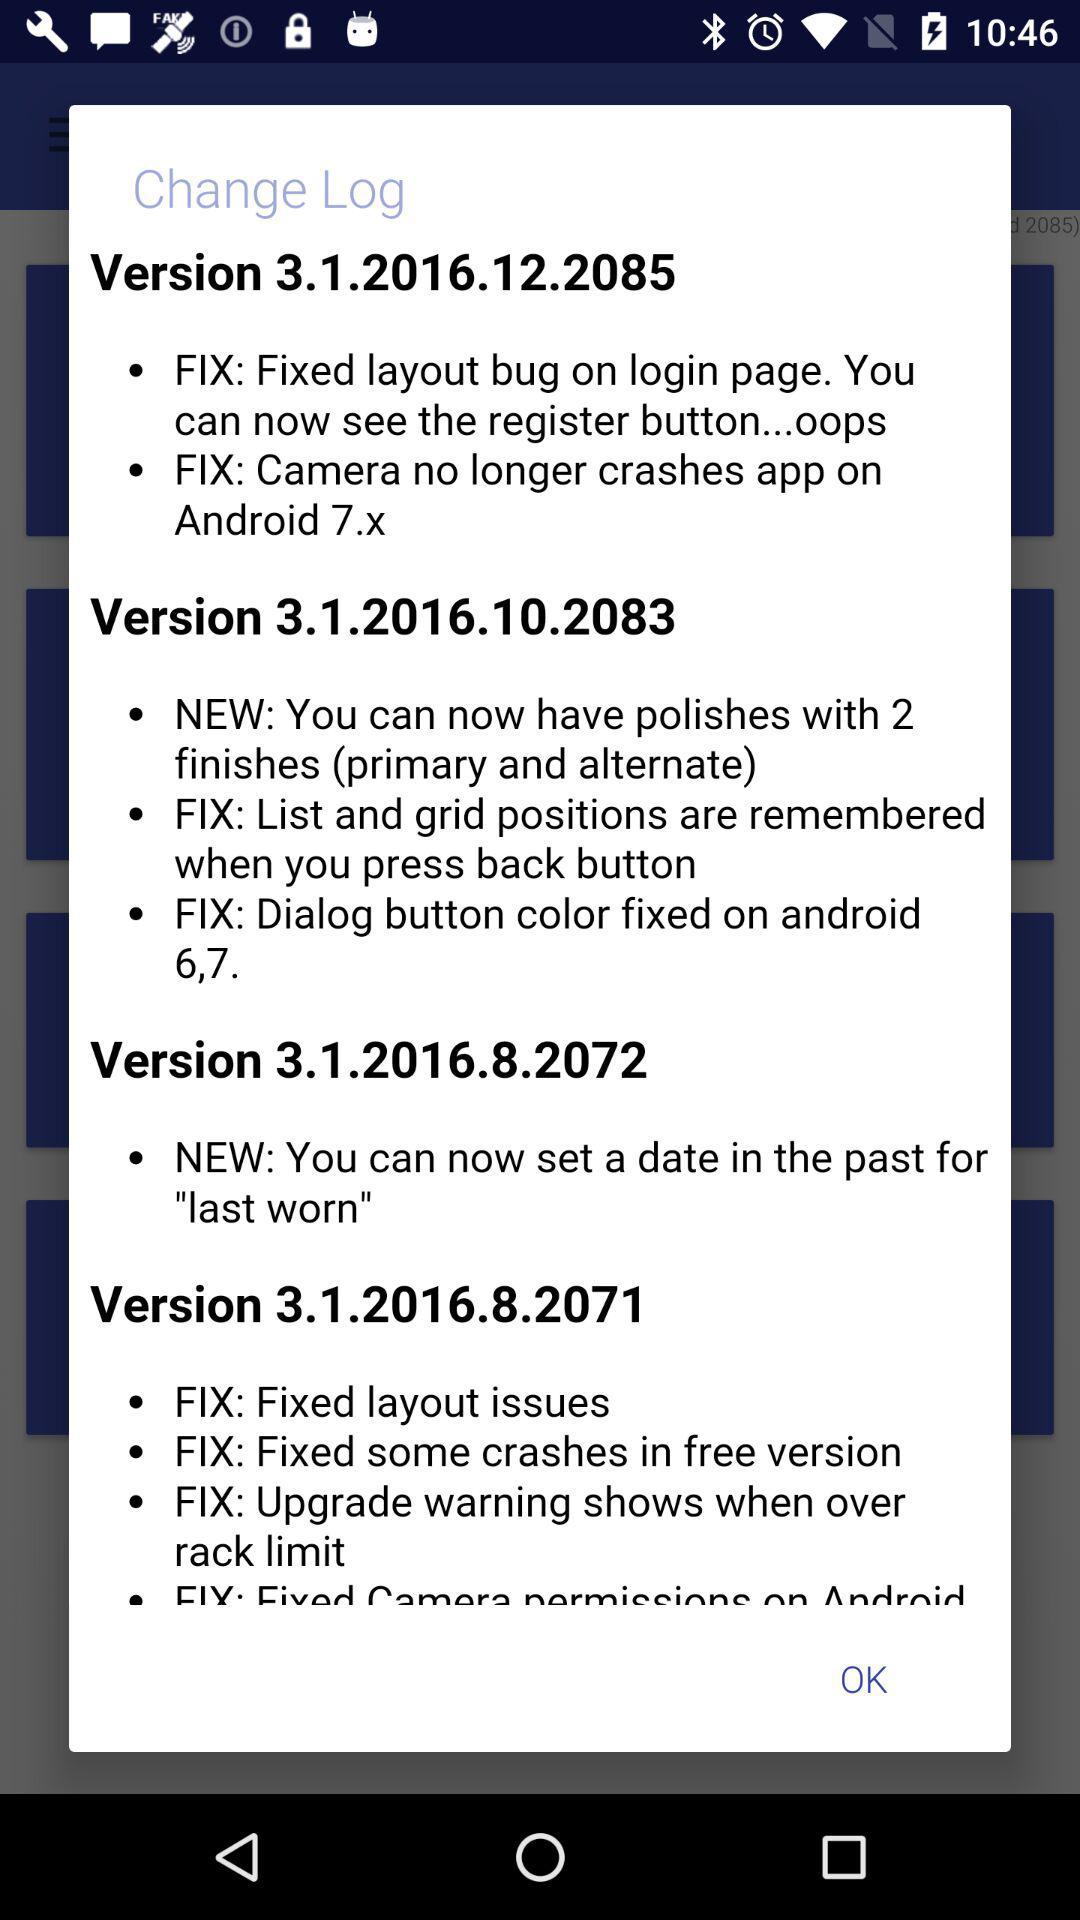What is the latest version of the application in use? The latest version of the application in use is 3.1.2016.12.2085. 